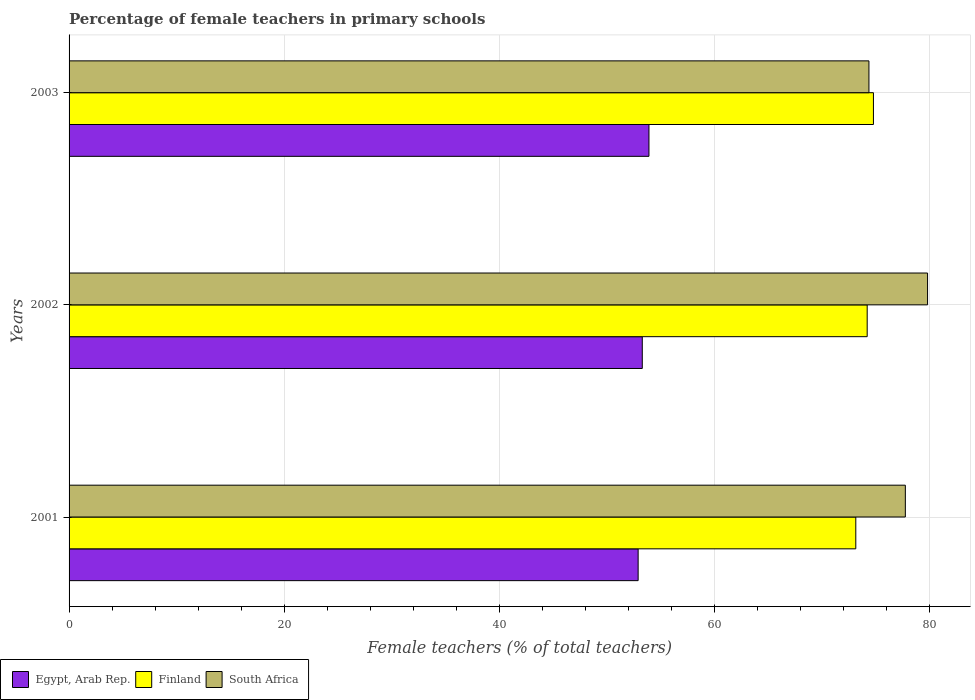How many different coloured bars are there?
Your response must be concise. 3. How many bars are there on the 2nd tick from the bottom?
Your response must be concise. 3. What is the label of the 1st group of bars from the top?
Give a very brief answer. 2003. What is the percentage of female teachers in South Africa in 2003?
Make the answer very short. 74.38. Across all years, what is the maximum percentage of female teachers in South Africa?
Your response must be concise. 79.83. Across all years, what is the minimum percentage of female teachers in South Africa?
Offer a terse response. 74.38. In which year was the percentage of female teachers in South Africa maximum?
Keep it short and to the point. 2002. What is the total percentage of female teachers in Finland in the graph?
Your answer should be very brief. 222.18. What is the difference between the percentage of female teachers in South Africa in 2001 and that in 2003?
Keep it short and to the point. 3.39. What is the difference between the percentage of female teachers in South Africa in 2003 and the percentage of female teachers in Finland in 2002?
Your answer should be compact. 0.16. What is the average percentage of female teachers in Finland per year?
Give a very brief answer. 74.06. In the year 2002, what is the difference between the percentage of female teachers in Egypt, Arab Rep. and percentage of female teachers in Finland?
Make the answer very short. -20.91. In how many years, is the percentage of female teachers in Finland greater than 28 %?
Provide a short and direct response. 3. What is the ratio of the percentage of female teachers in Finland in 2002 to that in 2003?
Provide a succinct answer. 0.99. Is the percentage of female teachers in Finland in 2002 less than that in 2003?
Your answer should be compact. Yes. Is the difference between the percentage of female teachers in Egypt, Arab Rep. in 2002 and 2003 greater than the difference between the percentage of female teachers in Finland in 2002 and 2003?
Ensure brevity in your answer.  No. What is the difference between the highest and the second highest percentage of female teachers in Egypt, Arab Rep.?
Provide a short and direct response. 0.62. What is the difference between the highest and the lowest percentage of female teachers in South Africa?
Keep it short and to the point. 5.45. In how many years, is the percentage of female teachers in South Africa greater than the average percentage of female teachers in South Africa taken over all years?
Make the answer very short. 2. What does the 1st bar from the top in 2003 represents?
Ensure brevity in your answer.  South Africa. What does the 2nd bar from the bottom in 2002 represents?
Your answer should be very brief. Finland. Is it the case that in every year, the sum of the percentage of female teachers in South Africa and percentage of female teachers in Egypt, Arab Rep. is greater than the percentage of female teachers in Finland?
Your answer should be very brief. Yes. How many bars are there?
Provide a succinct answer. 9. Are all the bars in the graph horizontal?
Offer a very short reply. Yes. What is the difference between two consecutive major ticks on the X-axis?
Give a very brief answer. 20. Does the graph contain grids?
Offer a very short reply. Yes. Where does the legend appear in the graph?
Make the answer very short. Bottom left. How many legend labels are there?
Make the answer very short. 3. What is the title of the graph?
Offer a very short reply. Percentage of female teachers in primary schools. Does "Bhutan" appear as one of the legend labels in the graph?
Provide a succinct answer. No. What is the label or title of the X-axis?
Your answer should be very brief. Female teachers (% of total teachers). What is the Female teachers (% of total teachers) in Egypt, Arab Rep. in 2001?
Make the answer very short. 52.92. What is the Female teachers (% of total teachers) of Finland in 2001?
Your answer should be compact. 73.16. What is the Female teachers (% of total teachers) of South Africa in 2001?
Your answer should be compact. 77.77. What is the Female teachers (% of total teachers) in Egypt, Arab Rep. in 2002?
Your answer should be compact. 53.31. What is the Female teachers (% of total teachers) in Finland in 2002?
Your answer should be compact. 74.22. What is the Female teachers (% of total teachers) in South Africa in 2002?
Give a very brief answer. 79.83. What is the Female teachers (% of total teachers) in Egypt, Arab Rep. in 2003?
Provide a succinct answer. 53.93. What is the Female teachers (% of total teachers) in Finland in 2003?
Keep it short and to the point. 74.8. What is the Female teachers (% of total teachers) in South Africa in 2003?
Make the answer very short. 74.38. Across all years, what is the maximum Female teachers (% of total teachers) in Egypt, Arab Rep.?
Your response must be concise. 53.93. Across all years, what is the maximum Female teachers (% of total teachers) of Finland?
Offer a terse response. 74.8. Across all years, what is the maximum Female teachers (% of total teachers) of South Africa?
Keep it short and to the point. 79.83. Across all years, what is the minimum Female teachers (% of total teachers) of Egypt, Arab Rep.?
Provide a short and direct response. 52.92. Across all years, what is the minimum Female teachers (% of total teachers) in Finland?
Make the answer very short. 73.16. Across all years, what is the minimum Female teachers (% of total teachers) in South Africa?
Ensure brevity in your answer.  74.38. What is the total Female teachers (% of total teachers) in Egypt, Arab Rep. in the graph?
Offer a very short reply. 160.15. What is the total Female teachers (% of total teachers) of Finland in the graph?
Keep it short and to the point. 222.18. What is the total Female teachers (% of total teachers) of South Africa in the graph?
Offer a very short reply. 231.98. What is the difference between the Female teachers (% of total teachers) in Egypt, Arab Rep. in 2001 and that in 2002?
Keep it short and to the point. -0.39. What is the difference between the Female teachers (% of total teachers) in Finland in 2001 and that in 2002?
Ensure brevity in your answer.  -1.06. What is the difference between the Female teachers (% of total teachers) in South Africa in 2001 and that in 2002?
Give a very brief answer. -2.07. What is the difference between the Female teachers (% of total teachers) in Egypt, Arab Rep. in 2001 and that in 2003?
Provide a short and direct response. -1.01. What is the difference between the Female teachers (% of total teachers) in Finland in 2001 and that in 2003?
Your response must be concise. -1.64. What is the difference between the Female teachers (% of total teachers) of South Africa in 2001 and that in 2003?
Offer a very short reply. 3.39. What is the difference between the Female teachers (% of total teachers) of Egypt, Arab Rep. in 2002 and that in 2003?
Keep it short and to the point. -0.62. What is the difference between the Female teachers (% of total teachers) in Finland in 2002 and that in 2003?
Offer a very short reply. -0.58. What is the difference between the Female teachers (% of total teachers) of South Africa in 2002 and that in 2003?
Your answer should be compact. 5.45. What is the difference between the Female teachers (% of total teachers) in Egypt, Arab Rep. in 2001 and the Female teachers (% of total teachers) in Finland in 2002?
Make the answer very short. -21.3. What is the difference between the Female teachers (% of total teachers) of Egypt, Arab Rep. in 2001 and the Female teachers (% of total teachers) of South Africa in 2002?
Keep it short and to the point. -26.91. What is the difference between the Female teachers (% of total teachers) in Finland in 2001 and the Female teachers (% of total teachers) in South Africa in 2002?
Keep it short and to the point. -6.67. What is the difference between the Female teachers (% of total teachers) in Egypt, Arab Rep. in 2001 and the Female teachers (% of total teachers) in Finland in 2003?
Offer a very short reply. -21.88. What is the difference between the Female teachers (% of total teachers) in Egypt, Arab Rep. in 2001 and the Female teachers (% of total teachers) in South Africa in 2003?
Offer a terse response. -21.46. What is the difference between the Female teachers (% of total teachers) of Finland in 2001 and the Female teachers (% of total teachers) of South Africa in 2003?
Give a very brief answer. -1.22. What is the difference between the Female teachers (% of total teachers) of Egypt, Arab Rep. in 2002 and the Female teachers (% of total teachers) of Finland in 2003?
Provide a succinct answer. -21.49. What is the difference between the Female teachers (% of total teachers) of Egypt, Arab Rep. in 2002 and the Female teachers (% of total teachers) of South Africa in 2003?
Make the answer very short. -21.08. What is the difference between the Female teachers (% of total teachers) in Finland in 2002 and the Female teachers (% of total teachers) in South Africa in 2003?
Offer a terse response. -0.16. What is the average Female teachers (% of total teachers) of Egypt, Arab Rep. per year?
Provide a succinct answer. 53.38. What is the average Female teachers (% of total teachers) of Finland per year?
Give a very brief answer. 74.06. What is the average Female teachers (% of total teachers) of South Africa per year?
Offer a terse response. 77.33. In the year 2001, what is the difference between the Female teachers (% of total teachers) in Egypt, Arab Rep. and Female teachers (% of total teachers) in Finland?
Your response must be concise. -20.24. In the year 2001, what is the difference between the Female teachers (% of total teachers) of Egypt, Arab Rep. and Female teachers (% of total teachers) of South Africa?
Make the answer very short. -24.85. In the year 2001, what is the difference between the Female teachers (% of total teachers) of Finland and Female teachers (% of total teachers) of South Africa?
Your answer should be compact. -4.61. In the year 2002, what is the difference between the Female teachers (% of total teachers) of Egypt, Arab Rep. and Female teachers (% of total teachers) of Finland?
Your response must be concise. -20.91. In the year 2002, what is the difference between the Female teachers (% of total teachers) of Egypt, Arab Rep. and Female teachers (% of total teachers) of South Africa?
Your answer should be very brief. -26.53. In the year 2002, what is the difference between the Female teachers (% of total teachers) in Finland and Female teachers (% of total teachers) in South Africa?
Ensure brevity in your answer.  -5.61. In the year 2003, what is the difference between the Female teachers (% of total teachers) in Egypt, Arab Rep. and Female teachers (% of total teachers) in Finland?
Your response must be concise. -20.87. In the year 2003, what is the difference between the Female teachers (% of total teachers) in Egypt, Arab Rep. and Female teachers (% of total teachers) in South Africa?
Give a very brief answer. -20.46. In the year 2003, what is the difference between the Female teachers (% of total teachers) of Finland and Female teachers (% of total teachers) of South Africa?
Give a very brief answer. 0.42. What is the ratio of the Female teachers (% of total teachers) in Finland in 2001 to that in 2002?
Give a very brief answer. 0.99. What is the ratio of the Female teachers (% of total teachers) in South Africa in 2001 to that in 2002?
Make the answer very short. 0.97. What is the ratio of the Female teachers (% of total teachers) of Egypt, Arab Rep. in 2001 to that in 2003?
Provide a succinct answer. 0.98. What is the ratio of the Female teachers (% of total teachers) in Finland in 2001 to that in 2003?
Keep it short and to the point. 0.98. What is the ratio of the Female teachers (% of total teachers) of South Africa in 2001 to that in 2003?
Make the answer very short. 1.05. What is the ratio of the Female teachers (% of total teachers) in Egypt, Arab Rep. in 2002 to that in 2003?
Ensure brevity in your answer.  0.99. What is the ratio of the Female teachers (% of total teachers) in Finland in 2002 to that in 2003?
Give a very brief answer. 0.99. What is the ratio of the Female teachers (% of total teachers) in South Africa in 2002 to that in 2003?
Offer a terse response. 1.07. What is the difference between the highest and the second highest Female teachers (% of total teachers) in Egypt, Arab Rep.?
Your answer should be very brief. 0.62. What is the difference between the highest and the second highest Female teachers (% of total teachers) in Finland?
Give a very brief answer. 0.58. What is the difference between the highest and the second highest Female teachers (% of total teachers) of South Africa?
Offer a very short reply. 2.07. What is the difference between the highest and the lowest Female teachers (% of total teachers) in Egypt, Arab Rep.?
Provide a short and direct response. 1.01. What is the difference between the highest and the lowest Female teachers (% of total teachers) in Finland?
Offer a very short reply. 1.64. What is the difference between the highest and the lowest Female teachers (% of total teachers) in South Africa?
Make the answer very short. 5.45. 